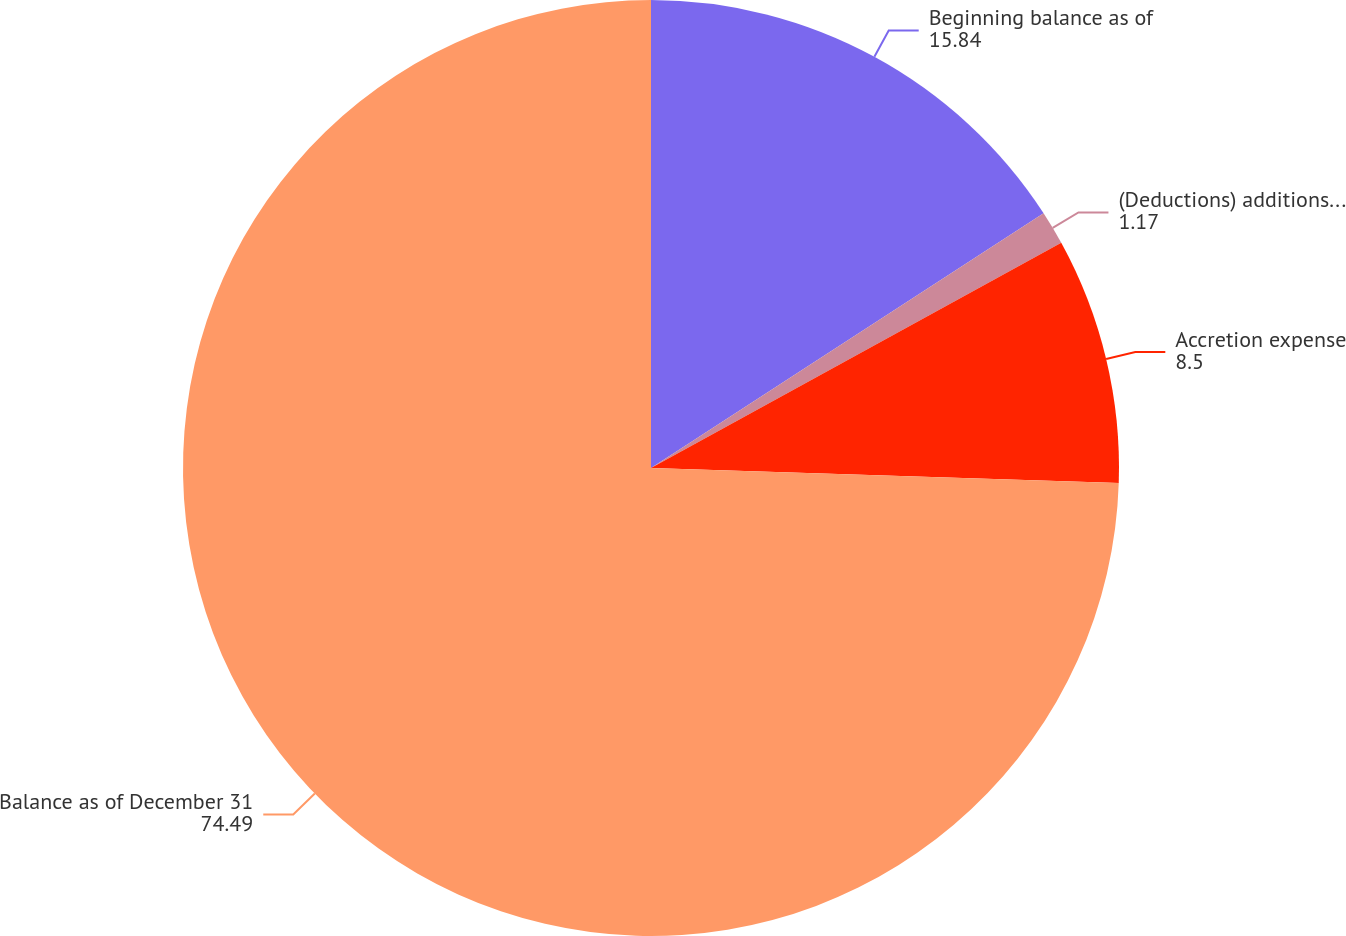Convert chart. <chart><loc_0><loc_0><loc_500><loc_500><pie_chart><fcel>Beginning balance as of<fcel>(Deductions) additions and<fcel>Accretion expense<fcel>Balance as of December 31<nl><fcel>15.84%<fcel>1.17%<fcel>8.5%<fcel>74.49%<nl></chart> 